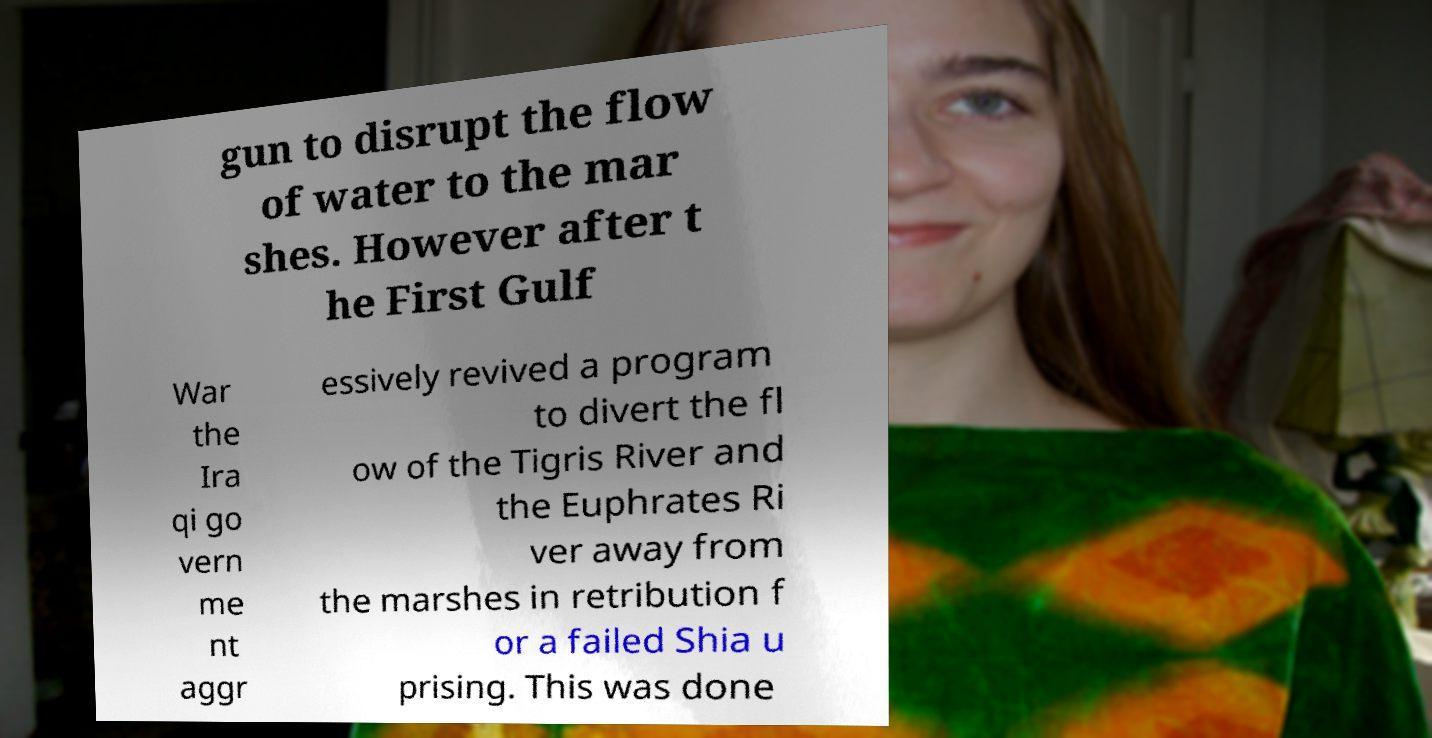Can you read and provide the text displayed in the image?This photo seems to have some interesting text. Can you extract and type it out for me? gun to disrupt the flow of water to the mar shes. However after t he First Gulf War the Ira qi go vern me nt aggr essively revived a program to divert the fl ow of the Tigris River and the Euphrates Ri ver away from the marshes in retribution f or a failed Shia u prising. This was done 